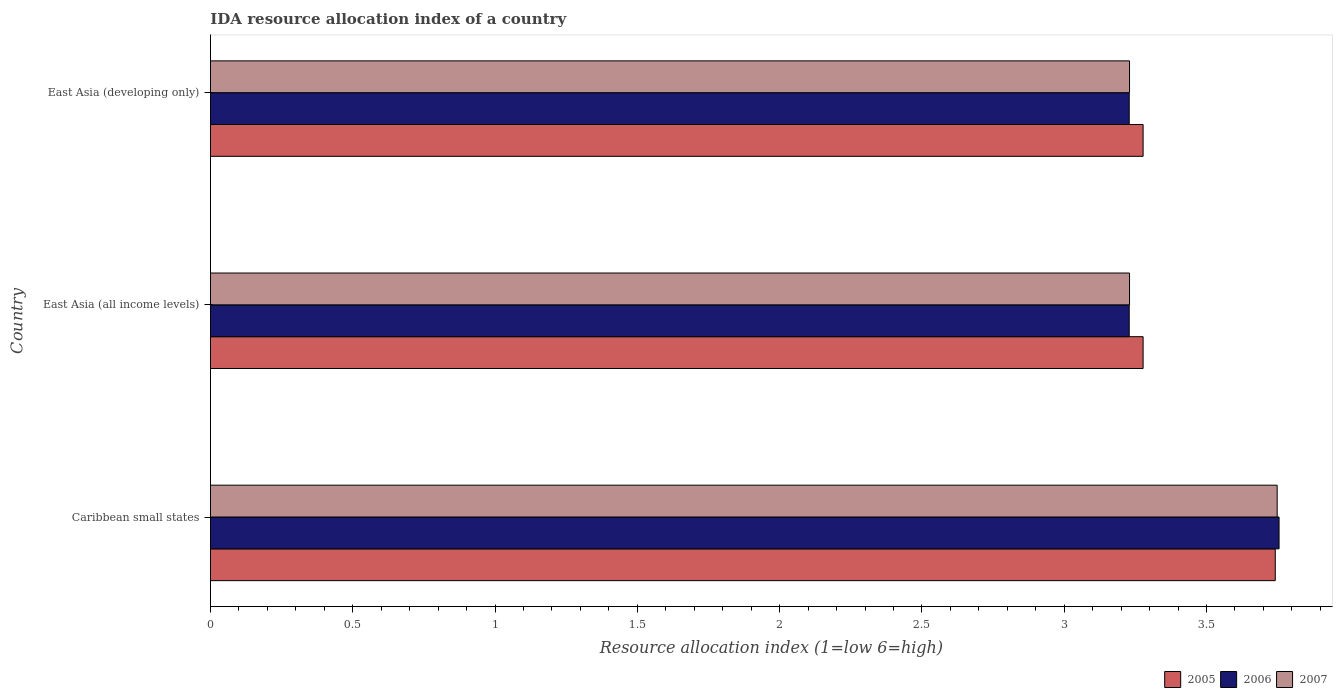Are the number of bars on each tick of the Y-axis equal?
Provide a short and direct response. Yes. How many bars are there on the 1st tick from the top?
Keep it short and to the point. 3. How many bars are there on the 2nd tick from the bottom?
Give a very brief answer. 3. What is the label of the 3rd group of bars from the top?
Provide a succinct answer. Caribbean small states. What is the IDA resource allocation index in 2005 in Caribbean small states?
Keep it short and to the point. 3.74. Across all countries, what is the maximum IDA resource allocation index in 2006?
Provide a short and direct response. 3.75. Across all countries, what is the minimum IDA resource allocation index in 2006?
Make the answer very short. 3.23. In which country was the IDA resource allocation index in 2005 maximum?
Provide a short and direct response. Caribbean small states. In which country was the IDA resource allocation index in 2006 minimum?
Provide a short and direct response. East Asia (all income levels). What is the total IDA resource allocation index in 2006 in the graph?
Keep it short and to the point. 10.21. What is the difference between the IDA resource allocation index in 2005 in East Asia (all income levels) and that in East Asia (developing only)?
Provide a succinct answer. 0. What is the difference between the IDA resource allocation index in 2007 in East Asia (all income levels) and the IDA resource allocation index in 2005 in East Asia (developing only)?
Offer a terse response. -0.05. What is the average IDA resource allocation index in 2005 per country?
Give a very brief answer. 3.43. What is the difference between the IDA resource allocation index in 2005 and IDA resource allocation index in 2007 in Caribbean small states?
Your response must be concise. -0.01. What is the ratio of the IDA resource allocation index in 2005 in Caribbean small states to that in East Asia (all income levels)?
Your response must be concise. 1.14. Is the difference between the IDA resource allocation index in 2005 in Caribbean small states and East Asia (developing only) greater than the difference between the IDA resource allocation index in 2007 in Caribbean small states and East Asia (developing only)?
Offer a very short reply. No. What is the difference between the highest and the second highest IDA resource allocation index in 2006?
Offer a terse response. 0.53. What is the difference between the highest and the lowest IDA resource allocation index in 2007?
Provide a succinct answer. 0.52. In how many countries, is the IDA resource allocation index in 2005 greater than the average IDA resource allocation index in 2005 taken over all countries?
Offer a very short reply. 1. Is the sum of the IDA resource allocation index in 2005 in East Asia (all income levels) and East Asia (developing only) greater than the maximum IDA resource allocation index in 2007 across all countries?
Offer a very short reply. Yes. What does the 2nd bar from the top in East Asia (all income levels) represents?
Keep it short and to the point. 2006. What does the 3rd bar from the bottom in Caribbean small states represents?
Your answer should be very brief. 2007. Are all the bars in the graph horizontal?
Offer a very short reply. Yes. What is the difference between two consecutive major ticks on the X-axis?
Make the answer very short. 0.5. Does the graph contain any zero values?
Keep it short and to the point. No. How many legend labels are there?
Offer a very short reply. 3. How are the legend labels stacked?
Provide a short and direct response. Horizontal. What is the title of the graph?
Make the answer very short. IDA resource allocation index of a country. What is the label or title of the X-axis?
Your answer should be very brief. Resource allocation index (1=low 6=high). What is the Resource allocation index (1=low 6=high) in 2005 in Caribbean small states?
Your answer should be very brief. 3.74. What is the Resource allocation index (1=low 6=high) of 2006 in Caribbean small states?
Offer a very short reply. 3.75. What is the Resource allocation index (1=low 6=high) in 2007 in Caribbean small states?
Your answer should be compact. 3.75. What is the Resource allocation index (1=low 6=high) in 2005 in East Asia (all income levels)?
Offer a very short reply. 3.28. What is the Resource allocation index (1=low 6=high) of 2006 in East Asia (all income levels)?
Make the answer very short. 3.23. What is the Resource allocation index (1=low 6=high) of 2007 in East Asia (all income levels)?
Provide a succinct answer. 3.23. What is the Resource allocation index (1=low 6=high) in 2005 in East Asia (developing only)?
Your response must be concise. 3.28. What is the Resource allocation index (1=low 6=high) in 2006 in East Asia (developing only)?
Provide a short and direct response. 3.23. What is the Resource allocation index (1=low 6=high) of 2007 in East Asia (developing only)?
Ensure brevity in your answer.  3.23. Across all countries, what is the maximum Resource allocation index (1=low 6=high) of 2005?
Offer a terse response. 3.74. Across all countries, what is the maximum Resource allocation index (1=low 6=high) of 2006?
Keep it short and to the point. 3.75. Across all countries, what is the maximum Resource allocation index (1=low 6=high) of 2007?
Give a very brief answer. 3.75. Across all countries, what is the minimum Resource allocation index (1=low 6=high) in 2005?
Give a very brief answer. 3.28. Across all countries, what is the minimum Resource allocation index (1=low 6=high) in 2006?
Provide a short and direct response. 3.23. Across all countries, what is the minimum Resource allocation index (1=low 6=high) in 2007?
Provide a succinct answer. 3.23. What is the total Resource allocation index (1=low 6=high) in 2005 in the graph?
Your response must be concise. 10.3. What is the total Resource allocation index (1=low 6=high) of 2006 in the graph?
Your answer should be compact. 10.21. What is the total Resource allocation index (1=low 6=high) of 2007 in the graph?
Make the answer very short. 10.21. What is the difference between the Resource allocation index (1=low 6=high) in 2005 in Caribbean small states and that in East Asia (all income levels)?
Your response must be concise. 0.46. What is the difference between the Resource allocation index (1=low 6=high) in 2006 in Caribbean small states and that in East Asia (all income levels)?
Your response must be concise. 0.53. What is the difference between the Resource allocation index (1=low 6=high) of 2007 in Caribbean small states and that in East Asia (all income levels)?
Ensure brevity in your answer.  0.52. What is the difference between the Resource allocation index (1=low 6=high) in 2005 in Caribbean small states and that in East Asia (developing only)?
Your answer should be very brief. 0.46. What is the difference between the Resource allocation index (1=low 6=high) in 2006 in Caribbean small states and that in East Asia (developing only)?
Make the answer very short. 0.53. What is the difference between the Resource allocation index (1=low 6=high) of 2007 in Caribbean small states and that in East Asia (developing only)?
Your answer should be very brief. 0.52. What is the difference between the Resource allocation index (1=low 6=high) in 2005 in Caribbean small states and the Resource allocation index (1=low 6=high) in 2006 in East Asia (all income levels)?
Your response must be concise. 0.51. What is the difference between the Resource allocation index (1=low 6=high) in 2005 in Caribbean small states and the Resource allocation index (1=low 6=high) in 2007 in East Asia (all income levels)?
Make the answer very short. 0.51. What is the difference between the Resource allocation index (1=low 6=high) in 2006 in Caribbean small states and the Resource allocation index (1=low 6=high) in 2007 in East Asia (all income levels)?
Offer a very short reply. 0.53. What is the difference between the Resource allocation index (1=low 6=high) in 2005 in Caribbean small states and the Resource allocation index (1=low 6=high) in 2006 in East Asia (developing only)?
Your response must be concise. 0.51. What is the difference between the Resource allocation index (1=low 6=high) in 2005 in Caribbean small states and the Resource allocation index (1=low 6=high) in 2007 in East Asia (developing only)?
Offer a very short reply. 0.51. What is the difference between the Resource allocation index (1=low 6=high) of 2006 in Caribbean small states and the Resource allocation index (1=low 6=high) of 2007 in East Asia (developing only)?
Your response must be concise. 0.53. What is the difference between the Resource allocation index (1=low 6=high) of 2005 in East Asia (all income levels) and the Resource allocation index (1=low 6=high) of 2006 in East Asia (developing only)?
Provide a short and direct response. 0.05. What is the difference between the Resource allocation index (1=low 6=high) of 2005 in East Asia (all income levels) and the Resource allocation index (1=low 6=high) of 2007 in East Asia (developing only)?
Your response must be concise. 0.05. What is the difference between the Resource allocation index (1=low 6=high) in 2006 in East Asia (all income levels) and the Resource allocation index (1=low 6=high) in 2007 in East Asia (developing only)?
Give a very brief answer. -0. What is the average Resource allocation index (1=low 6=high) in 2005 per country?
Offer a terse response. 3.43. What is the average Resource allocation index (1=low 6=high) of 2006 per country?
Give a very brief answer. 3.4. What is the average Resource allocation index (1=low 6=high) of 2007 per country?
Keep it short and to the point. 3.4. What is the difference between the Resource allocation index (1=low 6=high) in 2005 and Resource allocation index (1=low 6=high) in 2006 in Caribbean small states?
Your answer should be compact. -0.01. What is the difference between the Resource allocation index (1=low 6=high) in 2005 and Resource allocation index (1=low 6=high) in 2007 in Caribbean small states?
Make the answer very short. -0.01. What is the difference between the Resource allocation index (1=low 6=high) in 2006 and Resource allocation index (1=low 6=high) in 2007 in Caribbean small states?
Give a very brief answer. 0.01. What is the difference between the Resource allocation index (1=low 6=high) of 2005 and Resource allocation index (1=low 6=high) of 2006 in East Asia (all income levels)?
Your answer should be very brief. 0.05. What is the difference between the Resource allocation index (1=low 6=high) of 2005 and Resource allocation index (1=low 6=high) of 2007 in East Asia (all income levels)?
Provide a succinct answer. 0.05. What is the difference between the Resource allocation index (1=low 6=high) in 2006 and Resource allocation index (1=low 6=high) in 2007 in East Asia (all income levels)?
Ensure brevity in your answer.  -0. What is the difference between the Resource allocation index (1=low 6=high) in 2005 and Resource allocation index (1=low 6=high) in 2006 in East Asia (developing only)?
Your answer should be compact. 0.05. What is the difference between the Resource allocation index (1=low 6=high) in 2005 and Resource allocation index (1=low 6=high) in 2007 in East Asia (developing only)?
Your answer should be very brief. 0.05. What is the difference between the Resource allocation index (1=low 6=high) in 2006 and Resource allocation index (1=low 6=high) in 2007 in East Asia (developing only)?
Provide a succinct answer. -0. What is the ratio of the Resource allocation index (1=low 6=high) in 2005 in Caribbean small states to that in East Asia (all income levels)?
Provide a succinct answer. 1.14. What is the ratio of the Resource allocation index (1=low 6=high) of 2006 in Caribbean small states to that in East Asia (all income levels)?
Ensure brevity in your answer.  1.16. What is the ratio of the Resource allocation index (1=low 6=high) in 2007 in Caribbean small states to that in East Asia (all income levels)?
Provide a succinct answer. 1.16. What is the ratio of the Resource allocation index (1=low 6=high) of 2005 in Caribbean small states to that in East Asia (developing only)?
Offer a terse response. 1.14. What is the ratio of the Resource allocation index (1=low 6=high) of 2006 in Caribbean small states to that in East Asia (developing only)?
Your answer should be very brief. 1.16. What is the ratio of the Resource allocation index (1=low 6=high) in 2007 in Caribbean small states to that in East Asia (developing only)?
Make the answer very short. 1.16. What is the ratio of the Resource allocation index (1=low 6=high) of 2006 in East Asia (all income levels) to that in East Asia (developing only)?
Your answer should be very brief. 1. What is the difference between the highest and the second highest Resource allocation index (1=low 6=high) in 2005?
Keep it short and to the point. 0.46. What is the difference between the highest and the second highest Resource allocation index (1=low 6=high) of 2006?
Ensure brevity in your answer.  0.53. What is the difference between the highest and the second highest Resource allocation index (1=low 6=high) in 2007?
Ensure brevity in your answer.  0.52. What is the difference between the highest and the lowest Resource allocation index (1=low 6=high) in 2005?
Provide a short and direct response. 0.46. What is the difference between the highest and the lowest Resource allocation index (1=low 6=high) of 2006?
Offer a terse response. 0.53. What is the difference between the highest and the lowest Resource allocation index (1=low 6=high) of 2007?
Provide a succinct answer. 0.52. 